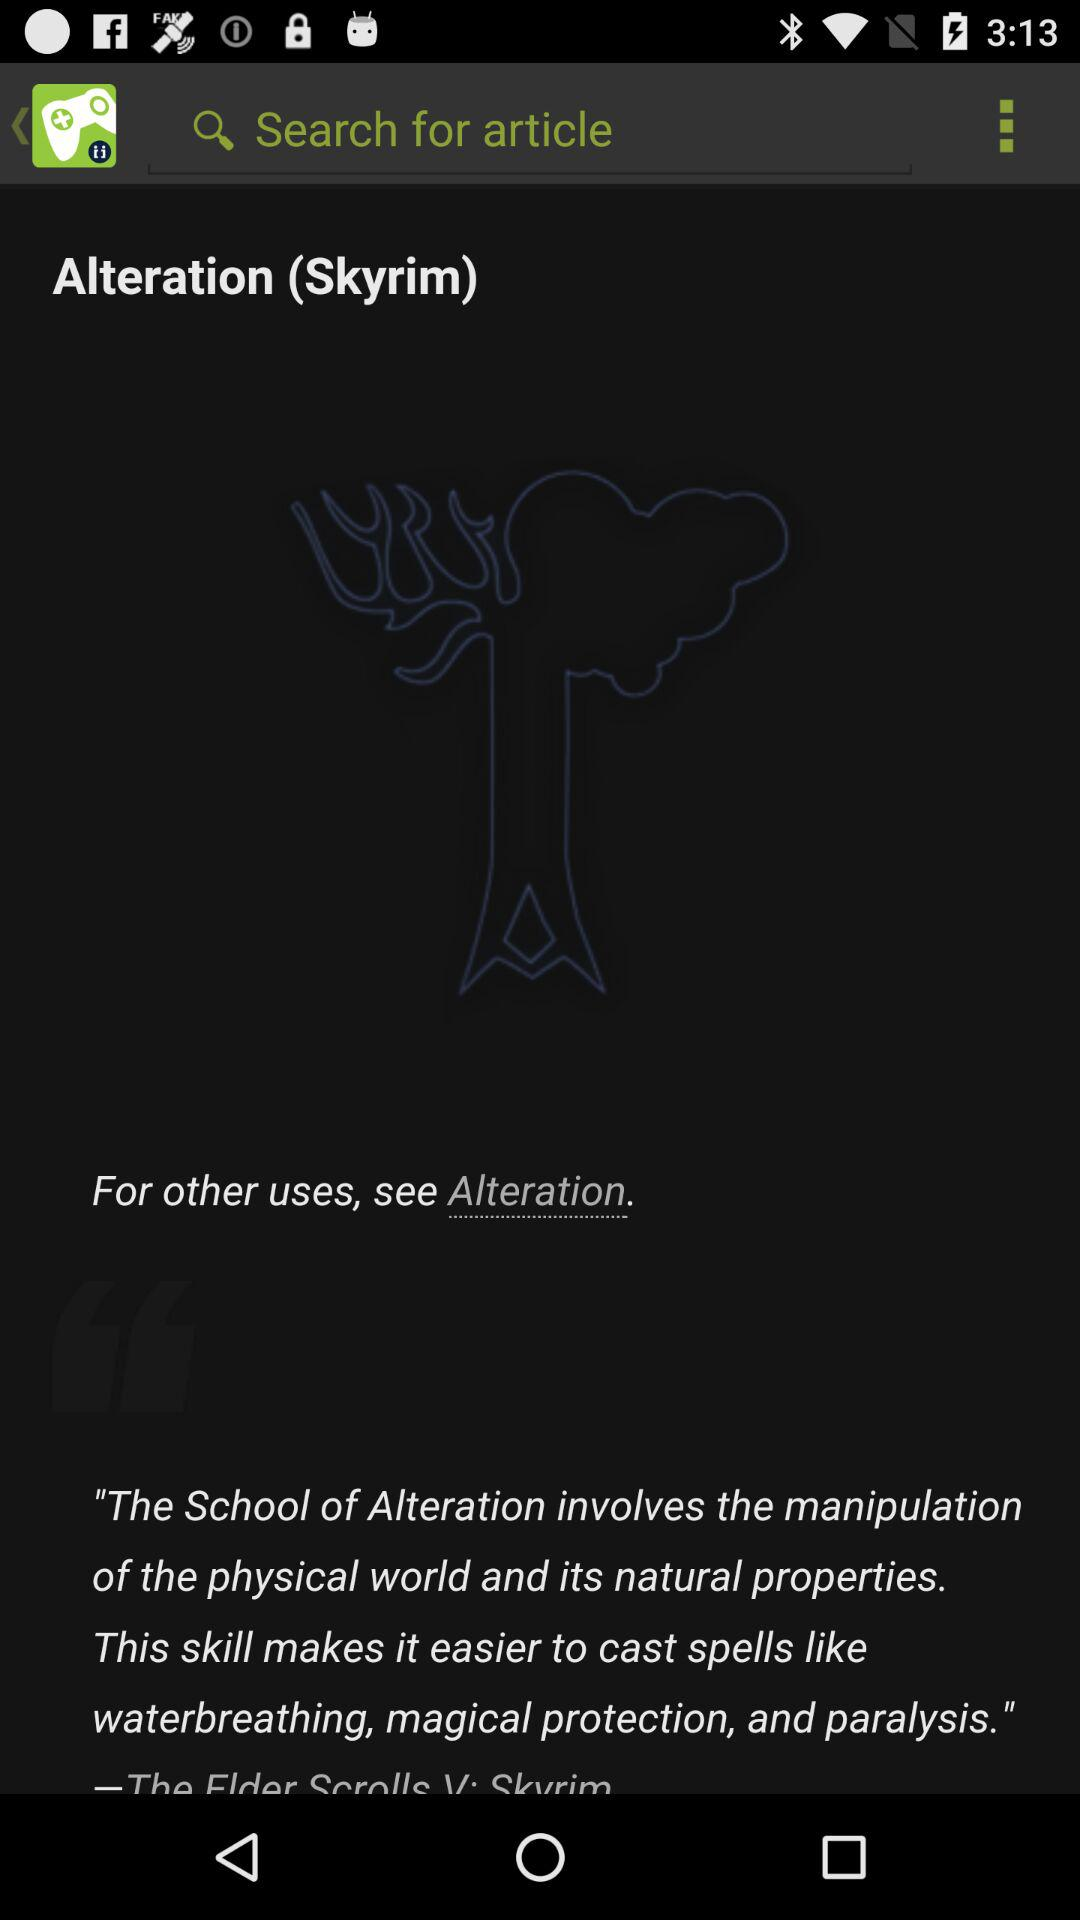What is the title of the article? The title of the article is "Alteration (Skyrim)". 